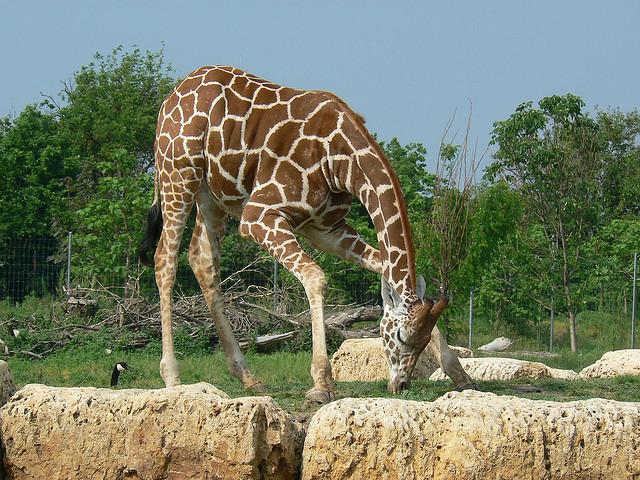What types of animals are in the picture?
Concise answer only. Giraffe. Does the giraffe have spots?
Keep it brief. Yes. Where is the goose?
Keep it brief. Behind giraffe. 